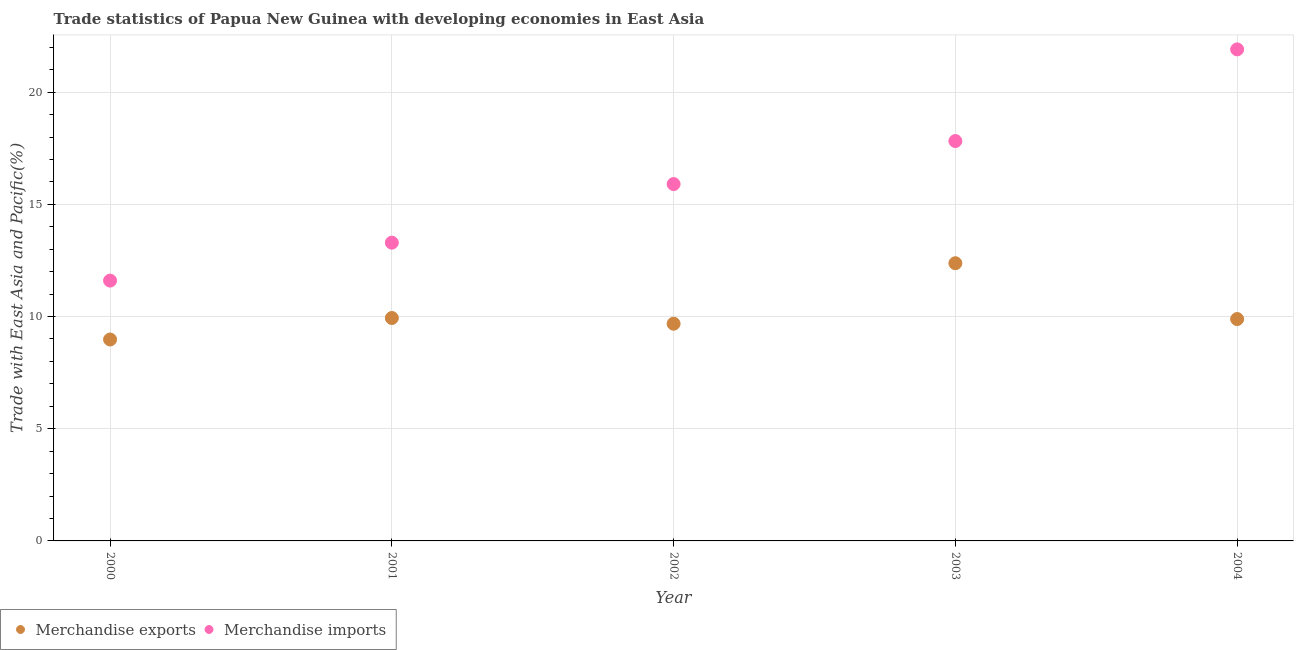What is the merchandise exports in 2002?
Provide a short and direct response. 9.68. Across all years, what is the maximum merchandise imports?
Provide a short and direct response. 21.91. Across all years, what is the minimum merchandise imports?
Your answer should be very brief. 11.6. In which year was the merchandise imports maximum?
Your answer should be compact. 2004. What is the total merchandise imports in the graph?
Your answer should be very brief. 80.53. What is the difference between the merchandise exports in 2001 and that in 2002?
Make the answer very short. 0.26. What is the difference between the merchandise exports in 2000 and the merchandise imports in 2004?
Offer a terse response. -12.93. What is the average merchandise imports per year?
Provide a short and direct response. 16.11. In the year 2003, what is the difference between the merchandise imports and merchandise exports?
Your answer should be compact. 5.45. What is the ratio of the merchandise imports in 2000 to that in 2004?
Provide a succinct answer. 0.53. Is the difference between the merchandise exports in 2003 and 2004 greater than the difference between the merchandise imports in 2003 and 2004?
Your response must be concise. Yes. What is the difference between the highest and the second highest merchandise exports?
Keep it short and to the point. 2.44. What is the difference between the highest and the lowest merchandise exports?
Provide a short and direct response. 3.4. Is the sum of the merchandise exports in 2001 and 2003 greater than the maximum merchandise imports across all years?
Provide a short and direct response. Yes. Is the merchandise imports strictly greater than the merchandise exports over the years?
Offer a very short reply. Yes. How many dotlines are there?
Ensure brevity in your answer.  2. How many years are there in the graph?
Your response must be concise. 5. Does the graph contain any zero values?
Give a very brief answer. No. How are the legend labels stacked?
Ensure brevity in your answer.  Horizontal. What is the title of the graph?
Your response must be concise. Trade statistics of Papua New Guinea with developing economies in East Asia. Does "From human activities" appear as one of the legend labels in the graph?
Give a very brief answer. No. What is the label or title of the X-axis?
Make the answer very short. Year. What is the label or title of the Y-axis?
Make the answer very short. Trade with East Asia and Pacific(%). What is the Trade with East Asia and Pacific(%) of Merchandise exports in 2000?
Make the answer very short. 8.98. What is the Trade with East Asia and Pacific(%) in Merchandise imports in 2000?
Your answer should be compact. 11.6. What is the Trade with East Asia and Pacific(%) of Merchandise exports in 2001?
Provide a short and direct response. 9.94. What is the Trade with East Asia and Pacific(%) in Merchandise imports in 2001?
Make the answer very short. 13.29. What is the Trade with East Asia and Pacific(%) in Merchandise exports in 2002?
Your response must be concise. 9.68. What is the Trade with East Asia and Pacific(%) in Merchandise imports in 2002?
Make the answer very short. 15.9. What is the Trade with East Asia and Pacific(%) in Merchandise exports in 2003?
Provide a short and direct response. 12.38. What is the Trade with East Asia and Pacific(%) of Merchandise imports in 2003?
Offer a terse response. 17.82. What is the Trade with East Asia and Pacific(%) of Merchandise exports in 2004?
Offer a very short reply. 9.89. What is the Trade with East Asia and Pacific(%) in Merchandise imports in 2004?
Your response must be concise. 21.91. Across all years, what is the maximum Trade with East Asia and Pacific(%) in Merchandise exports?
Provide a succinct answer. 12.38. Across all years, what is the maximum Trade with East Asia and Pacific(%) in Merchandise imports?
Your answer should be compact. 21.91. Across all years, what is the minimum Trade with East Asia and Pacific(%) of Merchandise exports?
Ensure brevity in your answer.  8.98. Across all years, what is the minimum Trade with East Asia and Pacific(%) of Merchandise imports?
Provide a succinct answer. 11.6. What is the total Trade with East Asia and Pacific(%) in Merchandise exports in the graph?
Ensure brevity in your answer.  50.86. What is the total Trade with East Asia and Pacific(%) of Merchandise imports in the graph?
Make the answer very short. 80.53. What is the difference between the Trade with East Asia and Pacific(%) of Merchandise exports in 2000 and that in 2001?
Your response must be concise. -0.96. What is the difference between the Trade with East Asia and Pacific(%) in Merchandise imports in 2000 and that in 2001?
Ensure brevity in your answer.  -1.69. What is the difference between the Trade with East Asia and Pacific(%) in Merchandise exports in 2000 and that in 2002?
Keep it short and to the point. -0.7. What is the difference between the Trade with East Asia and Pacific(%) in Merchandise imports in 2000 and that in 2002?
Ensure brevity in your answer.  -4.3. What is the difference between the Trade with East Asia and Pacific(%) of Merchandise exports in 2000 and that in 2003?
Provide a succinct answer. -3.4. What is the difference between the Trade with East Asia and Pacific(%) of Merchandise imports in 2000 and that in 2003?
Make the answer very short. -6.22. What is the difference between the Trade with East Asia and Pacific(%) in Merchandise exports in 2000 and that in 2004?
Offer a very short reply. -0.91. What is the difference between the Trade with East Asia and Pacific(%) in Merchandise imports in 2000 and that in 2004?
Provide a succinct answer. -10.31. What is the difference between the Trade with East Asia and Pacific(%) in Merchandise exports in 2001 and that in 2002?
Keep it short and to the point. 0.26. What is the difference between the Trade with East Asia and Pacific(%) in Merchandise imports in 2001 and that in 2002?
Your response must be concise. -2.61. What is the difference between the Trade with East Asia and Pacific(%) in Merchandise exports in 2001 and that in 2003?
Provide a short and direct response. -2.44. What is the difference between the Trade with East Asia and Pacific(%) in Merchandise imports in 2001 and that in 2003?
Offer a terse response. -4.53. What is the difference between the Trade with East Asia and Pacific(%) in Merchandise exports in 2001 and that in 2004?
Your response must be concise. 0.05. What is the difference between the Trade with East Asia and Pacific(%) of Merchandise imports in 2001 and that in 2004?
Ensure brevity in your answer.  -8.61. What is the difference between the Trade with East Asia and Pacific(%) in Merchandise exports in 2002 and that in 2003?
Offer a very short reply. -2.7. What is the difference between the Trade with East Asia and Pacific(%) in Merchandise imports in 2002 and that in 2003?
Offer a very short reply. -1.92. What is the difference between the Trade with East Asia and Pacific(%) of Merchandise exports in 2002 and that in 2004?
Provide a short and direct response. -0.21. What is the difference between the Trade with East Asia and Pacific(%) of Merchandise imports in 2002 and that in 2004?
Provide a short and direct response. -6. What is the difference between the Trade with East Asia and Pacific(%) of Merchandise exports in 2003 and that in 2004?
Your response must be concise. 2.49. What is the difference between the Trade with East Asia and Pacific(%) in Merchandise imports in 2003 and that in 2004?
Give a very brief answer. -4.08. What is the difference between the Trade with East Asia and Pacific(%) of Merchandise exports in 2000 and the Trade with East Asia and Pacific(%) of Merchandise imports in 2001?
Give a very brief answer. -4.32. What is the difference between the Trade with East Asia and Pacific(%) in Merchandise exports in 2000 and the Trade with East Asia and Pacific(%) in Merchandise imports in 2002?
Ensure brevity in your answer.  -6.93. What is the difference between the Trade with East Asia and Pacific(%) in Merchandise exports in 2000 and the Trade with East Asia and Pacific(%) in Merchandise imports in 2003?
Make the answer very short. -8.85. What is the difference between the Trade with East Asia and Pacific(%) of Merchandise exports in 2000 and the Trade with East Asia and Pacific(%) of Merchandise imports in 2004?
Make the answer very short. -12.93. What is the difference between the Trade with East Asia and Pacific(%) in Merchandise exports in 2001 and the Trade with East Asia and Pacific(%) in Merchandise imports in 2002?
Ensure brevity in your answer.  -5.97. What is the difference between the Trade with East Asia and Pacific(%) in Merchandise exports in 2001 and the Trade with East Asia and Pacific(%) in Merchandise imports in 2003?
Make the answer very short. -7.89. What is the difference between the Trade with East Asia and Pacific(%) in Merchandise exports in 2001 and the Trade with East Asia and Pacific(%) in Merchandise imports in 2004?
Give a very brief answer. -11.97. What is the difference between the Trade with East Asia and Pacific(%) of Merchandise exports in 2002 and the Trade with East Asia and Pacific(%) of Merchandise imports in 2003?
Offer a very short reply. -8.14. What is the difference between the Trade with East Asia and Pacific(%) in Merchandise exports in 2002 and the Trade with East Asia and Pacific(%) in Merchandise imports in 2004?
Provide a succinct answer. -12.23. What is the difference between the Trade with East Asia and Pacific(%) of Merchandise exports in 2003 and the Trade with East Asia and Pacific(%) of Merchandise imports in 2004?
Make the answer very short. -9.53. What is the average Trade with East Asia and Pacific(%) in Merchandise exports per year?
Your response must be concise. 10.17. What is the average Trade with East Asia and Pacific(%) in Merchandise imports per year?
Provide a short and direct response. 16.11. In the year 2000, what is the difference between the Trade with East Asia and Pacific(%) of Merchandise exports and Trade with East Asia and Pacific(%) of Merchandise imports?
Provide a short and direct response. -2.62. In the year 2001, what is the difference between the Trade with East Asia and Pacific(%) in Merchandise exports and Trade with East Asia and Pacific(%) in Merchandise imports?
Offer a terse response. -3.36. In the year 2002, what is the difference between the Trade with East Asia and Pacific(%) of Merchandise exports and Trade with East Asia and Pacific(%) of Merchandise imports?
Your answer should be very brief. -6.22. In the year 2003, what is the difference between the Trade with East Asia and Pacific(%) of Merchandise exports and Trade with East Asia and Pacific(%) of Merchandise imports?
Provide a short and direct response. -5.45. In the year 2004, what is the difference between the Trade with East Asia and Pacific(%) in Merchandise exports and Trade with East Asia and Pacific(%) in Merchandise imports?
Your answer should be very brief. -12.02. What is the ratio of the Trade with East Asia and Pacific(%) in Merchandise exports in 2000 to that in 2001?
Your response must be concise. 0.9. What is the ratio of the Trade with East Asia and Pacific(%) in Merchandise imports in 2000 to that in 2001?
Your answer should be compact. 0.87. What is the ratio of the Trade with East Asia and Pacific(%) in Merchandise exports in 2000 to that in 2002?
Keep it short and to the point. 0.93. What is the ratio of the Trade with East Asia and Pacific(%) in Merchandise imports in 2000 to that in 2002?
Give a very brief answer. 0.73. What is the ratio of the Trade with East Asia and Pacific(%) of Merchandise exports in 2000 to that in 2003?
Offer a terse response. 0.73. What is the ratio of the Trade with East Asia and Pacific(%) in Merchandise imports in 2000 to that in 2003?
Ensure brevity in your answer.  0.65. What is the ratio of the Trade with East Asia and Pacific(%) in Merchandise exports in 2000 to that in 2004?
Give a very brief answer. 0.91. What is the ratio of the Trade with East Asia and Pacific(%) in Merchandise imports in 2000 to that in 2004?
Your answer should be compact. 0.53. What is the ratio of the Trade with East Asia and Pacific(%) in Merchandise exports in 2001 to that in 2002?
Your answer should be very brief. 1.03. What is the ratio of the Trade with East Asia and Pacific(%) in Merchandise imports in 2001 to that in 2002?
Provide a succinct answer. 0.84. What is the ratio of the Trade with East Asia and Pacific(%) in Merchandise exports in 2001 to that in 2003?
Provide a succinct answer. 0.8. What is the ratio of the Trade with East Asia and Pacific(%) of Merchandise imports in 2001 to that in 2003?
Offer a very short reply. 0.75. What is the ratio of the Trade with East Asia and Pacific(%) of Merchandise exports in 2001 to that in 2004?
Offer a very short reply. 1. What is the ratio of the Trade with East Asia and Pacific(%) of Merchandise imports in 2001 to that in 2004?
Your response must be concise. 0.61. What is the ratio of the Trade with East Asia and Pacific(%) of Merchandise exports in 2002 to that in 2003?
Make the answer very short. 0.78. What is the ratio of the Trade with East Asia and Pacific(%) in Merchandise imports in 2002 to that in 2003?
Ensure brevity in your answer.  0.89. What is the ratio of the Trade with East Asia and Pacific(%) of Merchandise exports in 2002 to that in 2004?
Provide a succinct answer. 0.98. What is the ratio of the Trade with East Asia and Pacific(%) in Merchandise imports in 2002 to that in 2004?
Your answer should be very brief. 0.73. What is the ratio of the Trade with East Asia and Pacific(%) in Merchandise exports in 2003 to that in 2004?
Keep it short and to the point. 1.25. What is the ratio of the Trade with East Asia and Pacific(%) of Merchandise imports in 2003 to that in 2004?
Ensure brevity in your answer.  0.81. What is the difference between the highest and the second highest Trade with East Asia and Pacific(%) in Merchandise exports?
Your response must be concise. 2.44. What is the difference between the highest and the second highest Trade with East Asia and Pacific(%) in Merchandise imports?
Your answer should be very brief. 4.08. What is the difference between the highest and the lowest Trade with East Asia and Pacific(%) of Merchandise exports?
Give a very brief answer. 3.4. What is the difference between the highest and the lowest Trade with East Asia and Pacific(%) of Merchandise imports?
Your answer should be very brief. 10.31. 